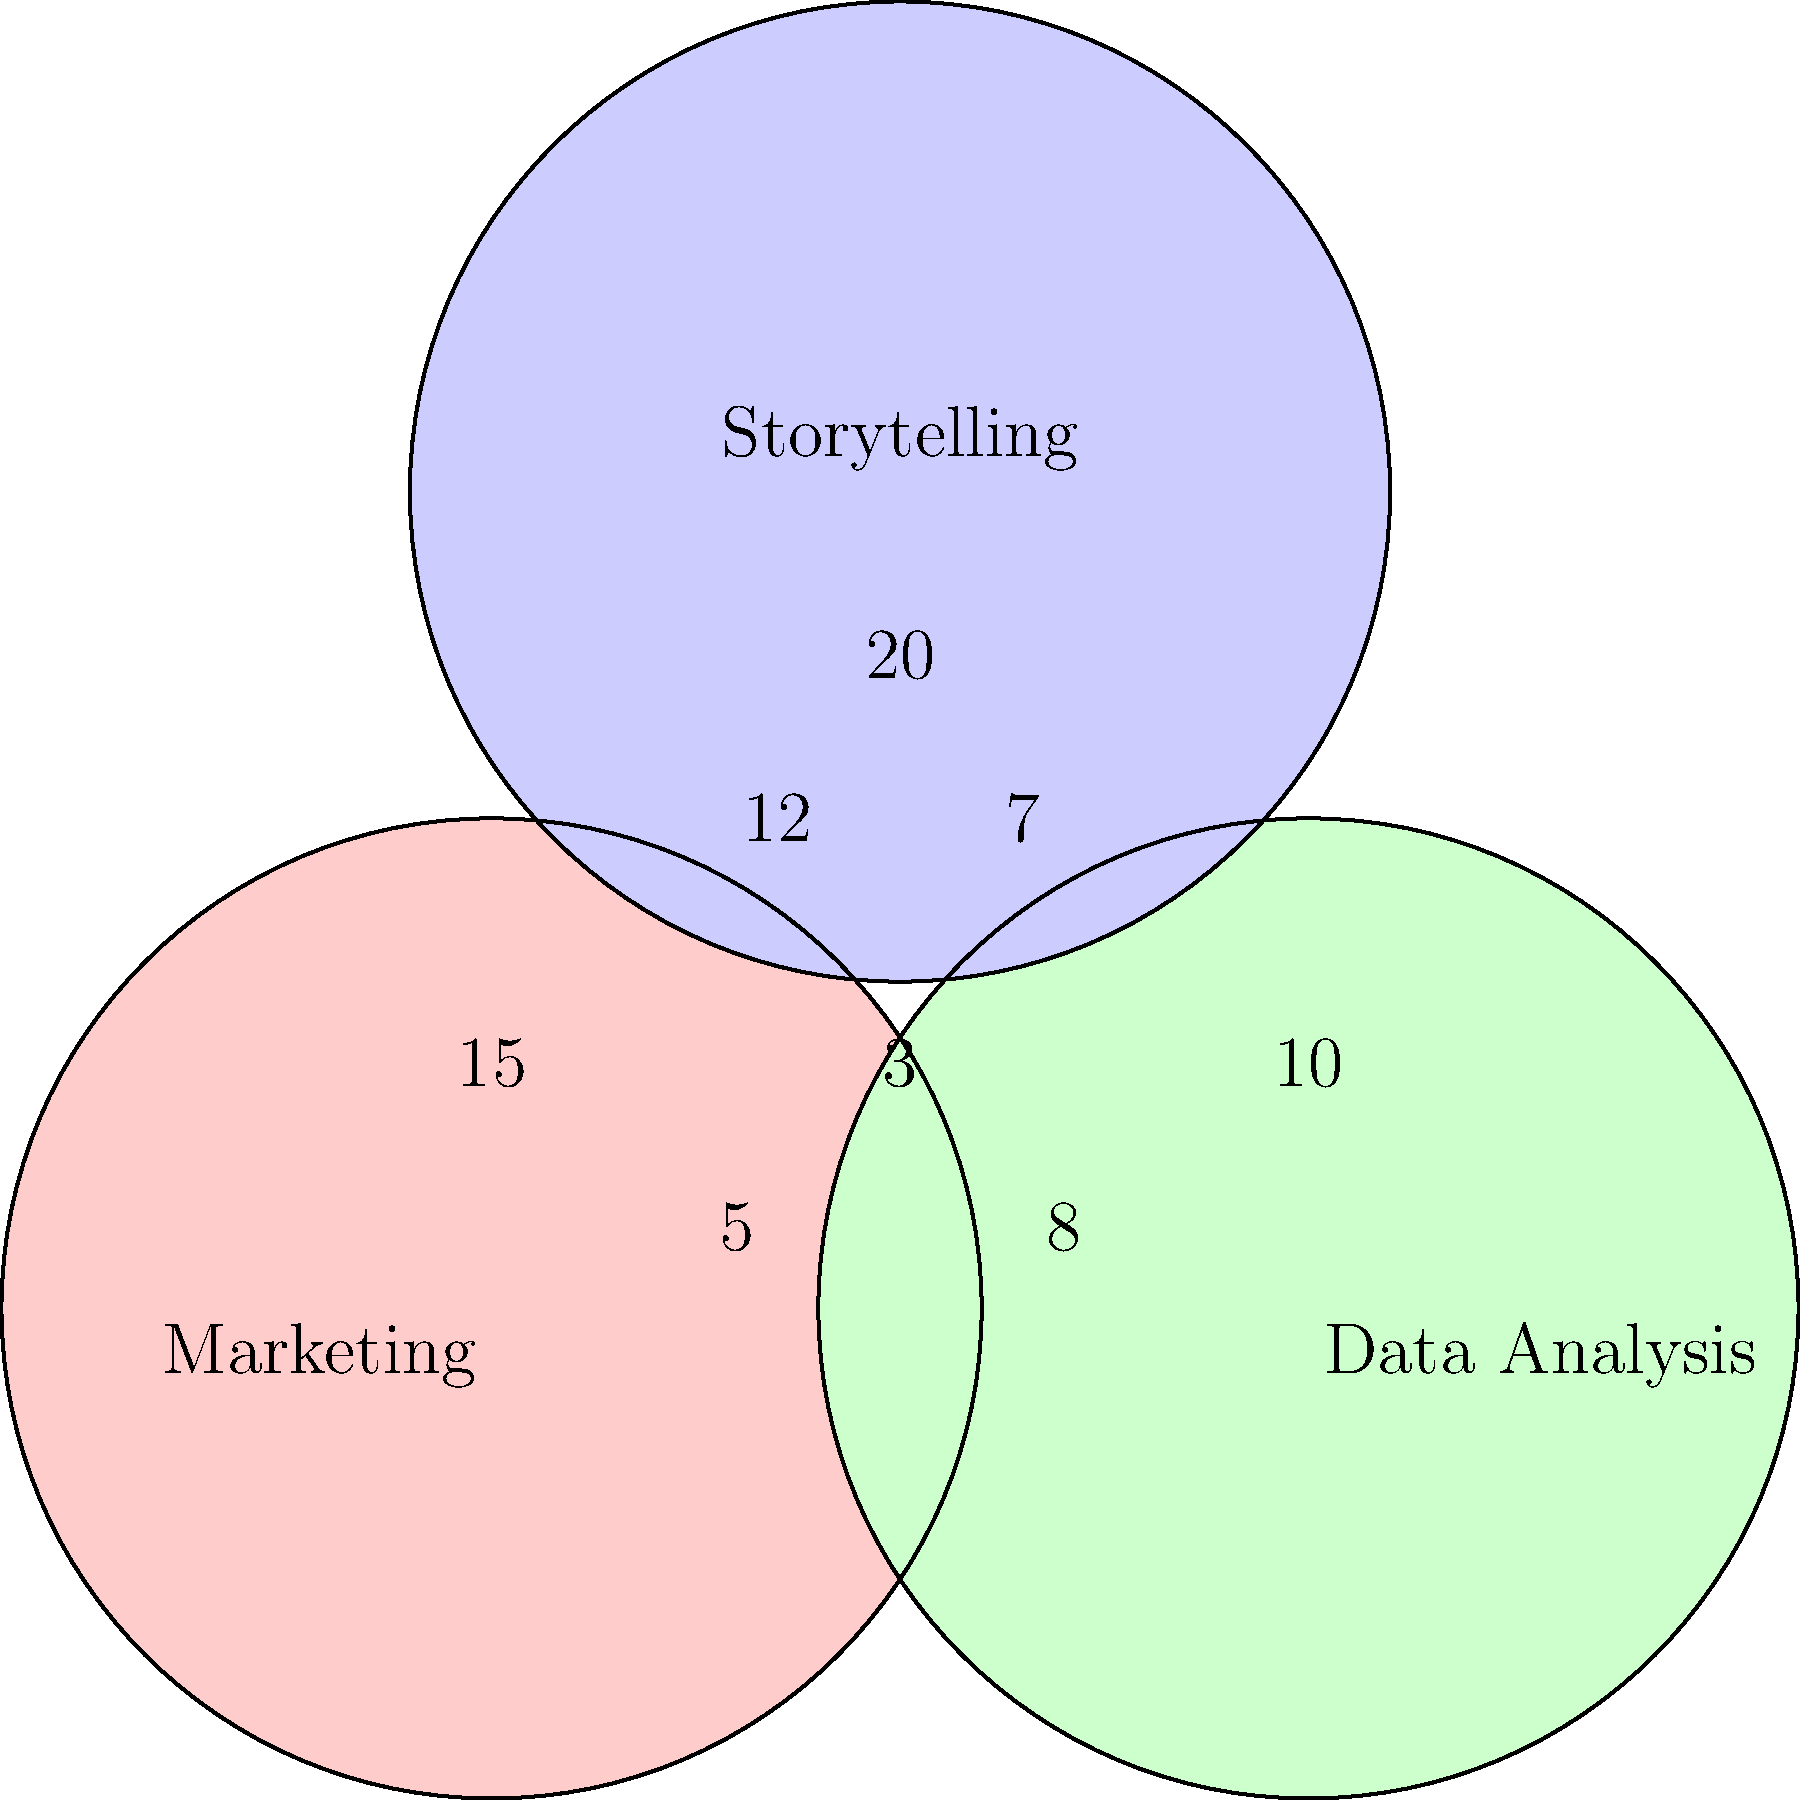As a career coach focusing on personal branding and storytelling, you're analyzing a Venn diagram representing skill overlaps in various professions. The diagram shows three intersecting circles: Marketing, Data Analysis, and Storytelling. Each region contains a number representing professionals with those specific skill combinations. How many professionals possess all three skills: Marketing, Data Analysis, and Storytelling? To find the number of professionals who possess all three skills, we need to identify the region where all three circles intersect. Let's break it down step-by-step:

1. The Venn diagram shows three overlapping circles representing Marketing, Data Analysis, and Storytelling skills.

2. Each region in the diagram contains a number, representing professionals with that specific skill combination.

3. The central region, where all three circles intersect, represents professionals who possess all three skills.

4. This central region contains the number 3.

Therefore, 3 professionals possess all three skills: Marketing, Data Analysis, and Storytelling.

This information is valuable for a career coach focusing on personal branding and storytelling, as it demonstrates the rarity and potential value of individuals who can combine these three skill sets. It could be used to highlight the unique selling points of clients who possess this combination of skills or to guide others in developing a more diverse skill set to stand out in the job market.
Answer: 3 professionals 